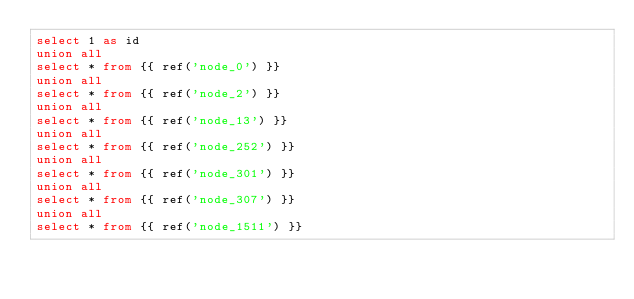Convert code to text. <code><loc_0><loc_0><loc_500><loc_500><_SQL_>select 1 as id
union all
select * from {{ ref('node_0') }}
union all
select * from {{ ref('node_2') }}
union all
select * from {{ ref('node_13') }}
union all
select * from {{ ref('node_252') }}
union all
select * from {{ ref('node_301') }}
union all
select * from {{ ref('node_307') }}
union all
select * from {{ ref('node_1511') }}</code> 